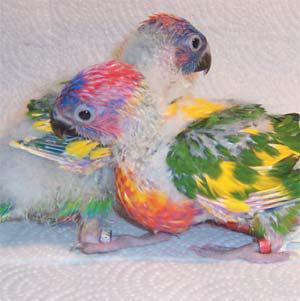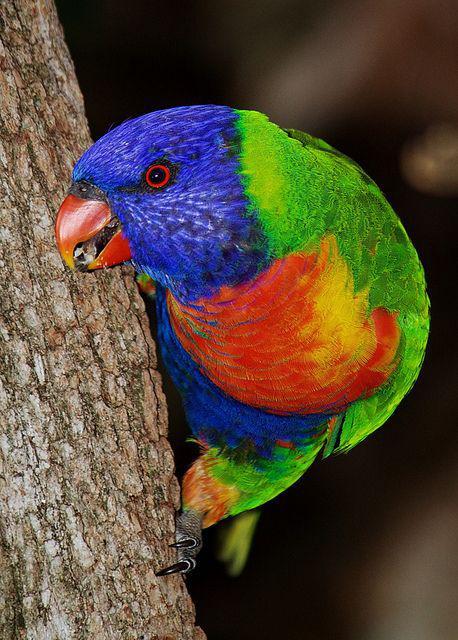The first image is the image on the left, the second image is the image on the right. Assess this claim about the two images: "There are a total of three birds". Correct or not? Answer yes or no. Yes. 